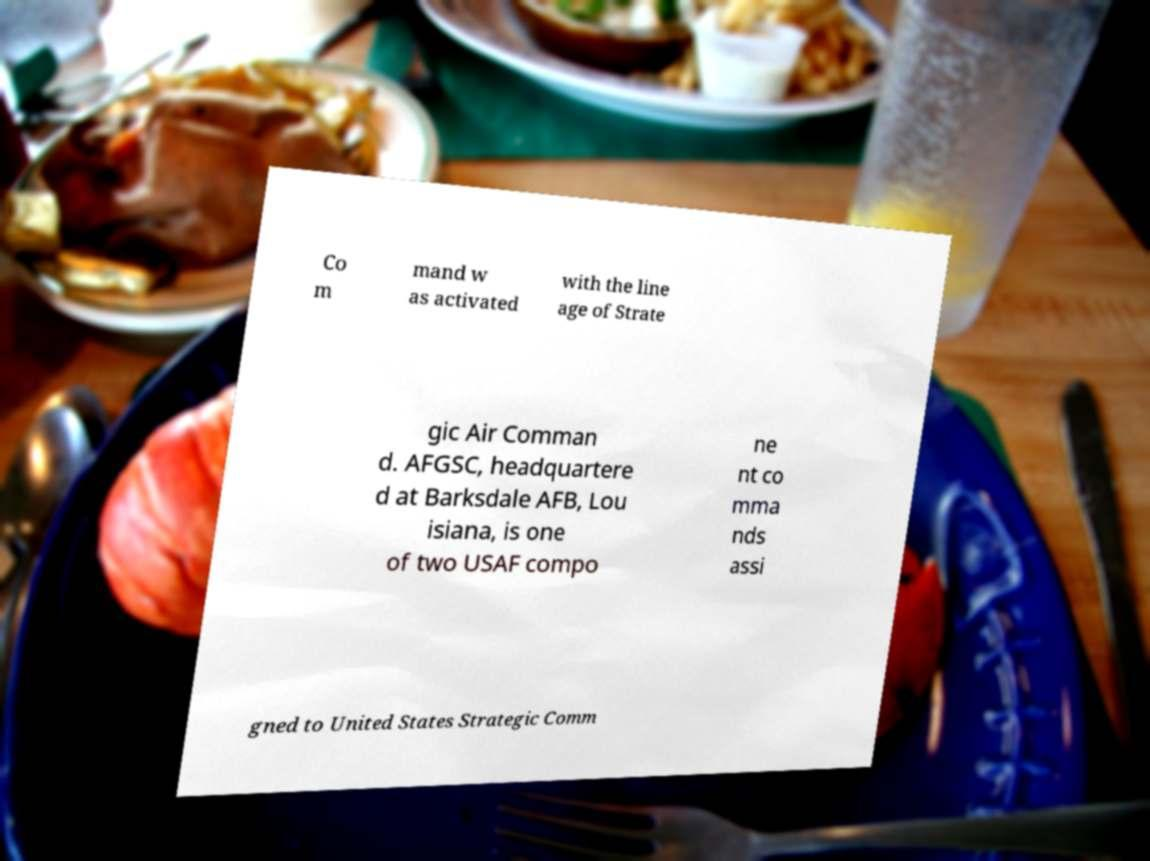What messages or text are displayed in this image? I need them in a readable, typed format. Co m mand w as activated with the line age of Strate gic Air Comman d. AFGSC, headquartere d at Barksdale AFB, Lou isiana, is one of two USAF compo ne nt co mma nds assi gned to United States Strategic Comm 